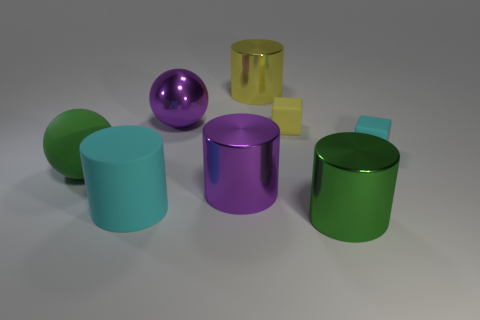Subtract all brown cylinders. Subtract all yellow spheres. How many cylinders are left? 4 Add 1 big purple things. How many objects exist? 9 Subtract all cubes. How many objects are left? 6 Add 1 tiny cyan things. How many tiny cyan things exist? 2 Subtract 0 brown cylinders. How many objects are left? 8 Subtract all large red shiny spheres. Subtract all big green cylinders. How many objects are left? 7 Add 7 big matte cylinders. How many big matte cylinders are left? 8 